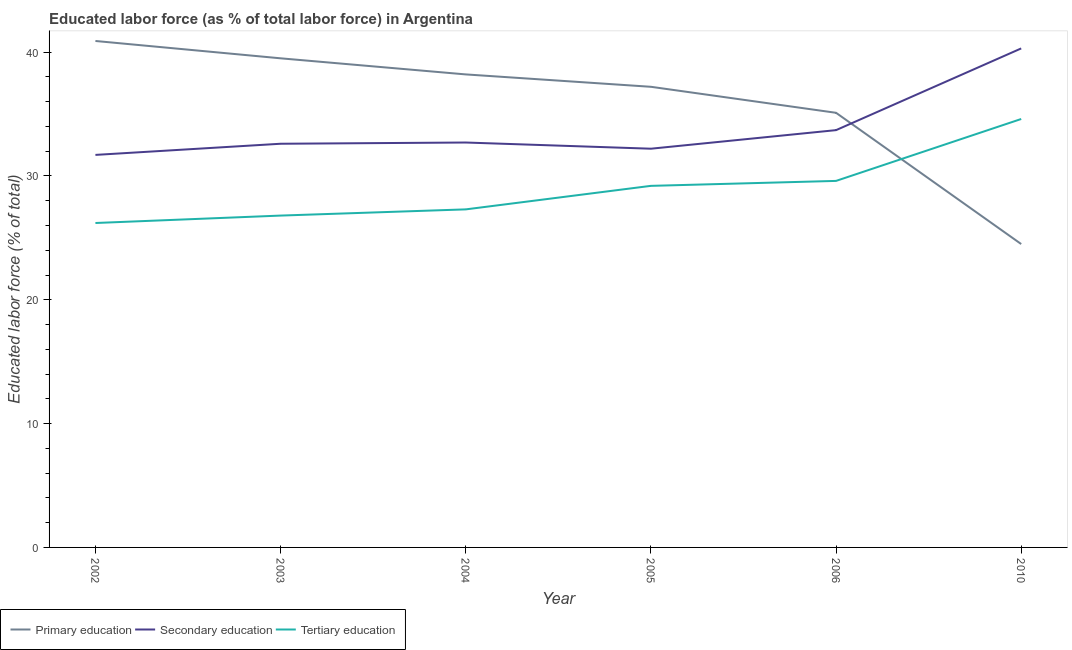Does the line corresponding to percentage of labor force who received secondary education intersect with the line corresponding to percentage of labor force who received tertiary education?
Ensure brevity in your answer.  No. Is the number of lines equal to the number of legend labels?
Offer a terse response. Yes. What is the percentage of labor force who received tertiary education in 2003?
Make the answer very short. 26.8. Across all years, what is the maximum percentage of labor force who received tertiary education?
Your answer should be compact. 34.6. Across all years, what is the minimum percentage of labor force who received tertiary education?
Your answer should be compact. 26.2. In which year was the percentage of labor force who received primary education maximum?
Keep it short and to the point. 2002. In which year was the percentage of labor force who received secondary education minimum?
Your response must be concise. 2002. What is the total percentage of labor force who received secondary education in the graph?
Give a very brief answer. 203.2. What is the difference between the percentage of labor force who received tertiary education in 2005 and that in 2006?
Ensure brevity in your answer.  -0.4. What is the difference between the percentage of labor force who received tertiary education in 2006 and the percentage of labor force who received secondary education in 2005?
Your answer should be compact. -2.6. What is the average percentage of labor force who received tertiary education per year?
Keep it short and to the point. 28.95. In the year 2004, what is the difference between the percentage of labor force who received primary education and percentage of labor force who received tertiary education?
Provide a succinct answer. 10.9. In how many years, is the percentage of labor force who received primary education greater than 10 %?
Offer a terse response. 6. What is the ratio of the percentage of labor force who received secondary education in 2002 to that in 2006?
Offer a very short reply. 0.94. Is the difference between the percentage of labor force who received primary education in 2006 and 2010 greater than the difference between the percentage of labor force who received secondary education in 2006 and 2010?
Give a very brief answer. Yes. What is the difference between the highest and the second highest percentage of labor force who received secondary education?
Your answer should be very brief. 6.6. What is the difference between the highest and the lowest percentage of labor force who received tertiary education?
Make the answer very short. 8.4. In how many years, is the percentage of labor force who received tertiary education greater than the average percentage of labor force who received tertiary education taken over all years?
Offer a terse response. 3. Is the percentage of labor force who received secondary education strictly greater than the percentage of labor force who received tertiary education over the years?
Offer a very short reply. Yes. Is the percentage of labor force who received secondary education strictly less than the percentage of labor force who received primary education over the years?
Your answer should be compact. No. How many years are there in the graph?
Provide a short and direct response. 6. What is the difference between two consecutive major ticks on the Y-axis?
Give a very brief answer. 10. Are the values on the major ticks of Y-axis written in scientific E-notation?
Make the answer very short. No. Does the graph contain any zero values?
Your response must be concise. No. Does the graph contain grids?
Keep it short and to the point. No. How many legend labels are there?
Keep it short and to the point. 3. How are the legend labels stacked?
Keep it short and to the point. Horizontal. What is the title of the graph?
Your response must be concise. Educated labor force (as % of total labor force) in Argentina. Does "Oil sources" appear as one of the legend labels in the graph?
Offer a very short reply. No. What is the label or title of the Y-axis?
Make the answer very short. Educated labor force (% of total). What is the Educated labor force (% of total) of Primary education in 2002?
Keep it short and to the point. 40.9. What is the Educated labor force (% of total) of Secondary education in 2002?
Your answer should be very brief. 31.7. What is the Educated labor force (% of total) of Tertiary education in 2002?
Make the answer very short. 26.2. What is the Educated labor force (% of total) of Primary education in 2003?
Your response must be concise. 39.5. What is the Educated labor force (% of total) in Secondary education in 2003?
Make the answer very short. 32.6. What is the Educated labor force (% of total) in Tertiary education in 2003?
Keep it short and to the point. 26.8. What is the Educated labor force (% of total) in Primary education in 2004?
Provide a succinct answer. 38.2. What is the Educated labor force (% of total) of Secondary education in 2004?
Make the answer very short. 32.7. What is the Educated labor force (% of total) of Tertiary education in 2004?
Offer a very short reply. 27.3. What is the Educated labor force (% of total) of Primary education in 2005?
Make the answer very short. 37.2. What is the Educated labor force (% of total) of Secondary education in 2005?
Make the answer very short. 32.2. What is the Educated labor force (% of total) of Tertiary education in 2005?
Keep it short and to the point. 29.2. What is the Educated labor force (% of total) of Primary education in 2006?
Provide a succinct answer. 35.1. What is the Educated labor force (% of total) in Secondary education in 2006?
Offer a terse response. 33.7. What is the Educated labor force (% of total) of Tertiary education in 2006?
Provide a succinct answer. 29.6. What is the Educated labor force (% of total) of Secondary education in 2010?
Make the answer very short. 40.3. What is the Educated labor force (% of total) of Tertiary education in 2010?
Your answer should be compact. 34.6. Across all years, what is the maximum Educated labor force (% of total) of Primary education?
Your response must be concise. 40.9. Across all years, what is the maximum Educated labor force (% of total) in Secondary education?
Offer a terse response. 40.3. Across all years, what is the maximum Educated labor force (% of total) in Tertiary education?
Keep it short and to the point. 34.6. Across all years, what is the minimum Educated labor force (% of total) of Primary education?
Your answer should be very brief. 24.5. Across all years, what is the minimum Educated labor force (% of total) in Secondary education?
Make the answer very short. 31.7. Across all years, what is the minimum Educated labor force (% of total) of Tertiary education?
Keep it short and to the point. 26.2. What is the total Educated labor force (% of total) of Primary education in the graph?
Your answer should be compact. 215.4. What is the total Educated labor force (% of total) of Secondary education in the graph?
Offer a very short reply. 203.2. What is the total Educated labor force (% of total) of Tertiary education in the graph?
Provide a succinct answer. 173.7. What is the difference between the Educated labor force (% of total) in Primary education in 2002 and that in 2003?
Offer a very short reply. 1.4. What is the difference between the Educated labor force (% of total) in Secondary education in 2002 and that in 2003?
Provide a short and direct response. -0.9. What is the difference between the Educated labor force (% of total) in Tertiary education in 2002 and that in 2003?
Provide a short and direct response. -0.6. What is the difference between the Educated labor force (% of total) in Secondary education in 2002 and that in 2004?
Your answer should be compact. -1. What is the difference between the Educated labor force (% of total) in Tertiary education in 2002 and that in 2004?
Your response must be concise. -1.1. What is the difference between the Educated labor force (% of total) of Primary education in 2002 and that in 2005?
Provide a short and direct response. 3.7. What is the difference between the Educated labor force (% of total) in Secondary education in 2002 and that in 2005?
Your answer should be very brief. -0.5. What is the difference between the Educated labor force (% of total) in Tertiary education in 2002 and that in 2006?
Offer a very short reply. -3.4. What is the difference between the Educated labor force (% of total) in Primary education in 2002 and that in 2010?
Ensure brevity in your answer.  16.4. What is the difference between the Educated labor force (% of total) in Secondary education in 2002 and that in 2010?
Provide a short and direct response. -8.6. What is the difference between the Educated labor force (% of total) in Secondary education in 2003 and that in 2004?
Make the answer very short. -0.1. What is the difference between the Educated labor force (% of total) of Primary education in 2003 and that in 2005?
Ensure brevity in your answer.  2.3. What is the difference between the Educated labor force (% of total) in Secondary education in 2003 and that in 2005?
Provide a short and direct response. 0.4. What is the difference between the Educated labor force (% of total) of Tertiary education in 2003 and that in 2005?
Provide a succinct answer. -2.4. What is the difference between the Educated labor force (% of total) of Primary education in 2003 and that in 2010?
Keep it short and to the point. 15. What is the difference between the Educated labor force (% of total) of Secondary education in 2003 and that in 2010?
Ensure brevity in your answer.  -7.7. What is the difference between the Educated labor force (% of total) in Tertiary education in 2003 and that in 2010?
Your response must be concise. -7.8. What is the difference between the Educated labor force (% of total) of Secondary education in 2004 and that in 2005?
Offer a terse response. 0.5. What is the difference between the Educated labor force (% of total) of Tertiary education in 2004 and that in 2005?
Make the answer very short. -1.9. What is the difference between the Educated labor force (% of total) of Secondary education in 2004 and that in 2006?
Your response must be concise. -1. What is the difference between the Educated labor force (% of total) of Tertiary education in 2004 and that in 2006?
Your response must be concise. -2.3. What is the difference between the Educated labor force (% of total) in Primary education in 2004 and that in 2010?
Keep it short and to the point. 13.7. What is the difference between the Educated labor force (% of total) of Secondary education in 2004 and that in 2010?
Your response must be concise. -7.6. What is the difference between the Educated labor force (% of total) of Secondary education in 2005 and that in 2006?
Keep it short and to the point. -1.5. What is the difference between the Educated labor force (% of total) of Primary education in 2005 and that in 2010?
Make the answer very short. 12.7. What is the difference between the Educated labor force (% of total) of Secondary education in 2005 and that in 2010?
Make the answer very short. -8.1. What is the difference between the Educated labor force (% of total) in Tertiary education in 2006 and that in 2010?
Offer a very short reply. -5. What is the difference between the Educated labor force (% of total) of Secondary education in 2002 and the Educated labor force (% of total) of Tertiary education in 2003?
Provide a short and direct response. 4.9. What is the difference between the Educated labor force (% of total) in Primary education in 2002 and the Educated labor force (% of total) in Secondary education in 2004?
Make the answer very short. 8.2. What is the difference between the Educated labor force (% of total) in Secondary education in 2002 and the Educated labor force (% of total) in Tertiary education in 2004?
Provide a short and direct response. 4.4. What is the difference between the Educated labor force (% of total) of Primary education in 2002 and the Educated labor force (% of total) of Secondary education in 2005?
Offer a very short reply. 8.7. What is the difference between the Educated labor force (% of total) in Secondary education in 2002 and the Educated labor force (% of total) in Tertiary education in 2005?
Your answer should be very brief. 2.5. What is the difference between the Educated labor force (% of total) of Primary education in 2002 and the Educated labor force (% of total) of Secondary education in 2006?
Make the answer very short. 7.2. What is the difference between the Educated labor force (% of total) in Secondary education in 2002 and the Educated labor force (% of total) in Tertiary education in 2006?
Offer a terse response. 2.1. What is the difference between the Educated labor force (% of total) of Primary education in 2002 and the Educated labor force (% of total) of Secondary education in 2010?
Keep it short and to the point. 0.6. What is the difference between the Educated labor force (% of total) in Primary education in 2002 and the Educated labor force (% of total) in Tertiary education in 2010?
Provide a succinct answer. 6.3. What is the difference between the Educated labor force (% of total) in Primary education in 2003 and the Educated labor force (% of total) in Tertiary education in 2004?
Keep it short and to the point. 12.2. What is the difference between the Educated labor force (% of total) of Secondary education in 2003 and the Educated labor force (% of total) of Tertiary education in 2004?
Your response must be concise. 5.3. What is the difference between the Educated labor force (% of total) in Primary education in 2003 and the Educated labor force (% of total) in Tertiary education in 2005?
Your response must be concise. 10.3. What is the difference between the Educated labor force (% of total) of Primary education in 2003 and the Educated labor force (% of total) of Tertiary education in 2006?
Ensure brevity in your answer.  9.9. What is the difference between the Educated labor force (% of total) of Primary education in 2003 and the Educated labor force (% of total) of Secondary education in 2010?
Provide a short and direct response. -0.8. What is the difference between the Educated labor force (% of total) of Secondary education in 2003 and the Educated labor force (% of total) of Tertiary education in 2010?
Keep it short and to the point. -2. What is the difference between the Educated labor force (% of total) of Primary education in 2004 and the Educated labor force (% of total) of Secondary education in 2006?
Keep it short and to the point. 4.5. What is the difference between the Educated labor force (% of total) in Primary education in 2004 and the Educated labor force (% of total) in Tertiary education in 2006?
Provide a succinct answer. 8.6. What is the difference between the Educated labor force (% of total) of Secondary education in 2004 and the Educated labor force (% of total) of Tertiary education in 2006?
Give a very brief answer. 3.1. What is the difference between the Educated labor force (% of total) of Primary education in 2004 and the Educated labor force (% of total) of Secondary education in 2010?
Offer a terse response. -2.1. What is the difference between the Educated labor force (% of total) in Secondary education in 2004 and the Educated labor force (% of total) in Tertiary education in 2010?
Offer a very short reply. -1.9. What is the difference between the Educated labor force (% of total) of Secondary education in 2005 and the Educated labor force (% of total) of Tertiary education in 2006?
Your answer should be very brief. 2.6. What is the difference between the Educated labor force (% of total) in Primary education in 2005 and the Educated labor force (% of total) in Secondary education in 2010?
Your response must be concise. -3.1. What is the difference between the Educated labor force (% of total) in Primary education in 2005 and the Educated labor force (% of total) in Tertiary education in 2010?
Provide a succinct answer. 2.6. What is the difference between the Educated labor force (% of total) in Secondary education in 2005 and the Educated labor force (% of total) in Tertiary education in 2010?
Make the answer very short. -2.4. What is the difference between the Educated labor force (% of total) of Primary education in 2006 and the Educated labor force (% of total) of Secondary education in 2010?
Make the answer very short. -5.2. What is the average Educated labor force (% of total) in Primary education per year?
Provide a short and direct response. 35.9. What is the average Educated labor force (% of total) of Secondary education per year?
Your answer should be compact. 33.87. What is the average Educated labor force (% of total) in Tertiary education per year?
Your answer should be very brief. 28.95. In the year 2002, what is the difference between the Educated labor force (% of total) in Primary education and Educated labor force (% of total) in Tertiary education?
Offer a terse response. 14.7. In the year 2002, what is the difference between the Educated labor force (% of total) in Secondary education and Educated labor force (% of total) in Tertiary education?
Provide a succinct answer. 5.5. In the year 2004, what is the difference between the Educated labor force (% of total) of Primary education and Educated labor force (% of total) of Secondary education?
Keep it short and to the point. 5.5. In the year 2004, what is the difference between the Educated labor force (% of total) of Primary education and Educated labor force (% of total) of Tertiary education?
Offer a very short reply. 10.9. In the year 2006, what is the difference between the Educated labor force (% of total) in Primary education and Educated labor force (% of total) in Secondary education?
Offer a terse response. 1.4. In the year 2010, what is the difference between the Educated labor force (% of total) in Primary education and Educated labor force (% of total) in Secondary education?
Keep it short and to the point. -15.8. In the year 2010, what is the difference between the Educated labor force (% of total) of Primary education and Educated labor force (% of total) of Tertiary education?
Make the answer very short. -10.1. In the year 2010, what is the difference between the Educated labor force (% of total) of Secondary education and Educated labor force (% of total) of Tertiary education?
Offer a terse response. 5.7. What is the ratio of the Educated labor force (% of total) of Primary education in 2002 to that in 2003?
Provide a short and direct response. 1.04. What is the ratio of the Educated labor force (% of total) of Secondary education in 2002 to that in 2003?
Provide a succinct answer. 0.97. What is the ratio of the Educated labor force (% of total) of Tertiary education in 2002 to that in 2003?
Keep it short and to the point. 0.98. What is the ratio of the Educated labor force (% of total) of Primary education in 2002 to that in 2004?
Offer a terse response. 1.07. What is the ratio of the Educated labor force (% of total) of Secondary education in 2002 to that in 2004?
Your answer should be compact. 0.97. What is the ratio of the Educated labor force (% of total) of Tertiary education in 2002 to that in 2004?
Your answer should be compact. 0.96. What is the ratio of the Educated labor force (% of total) of Primary education in 2002 to that in 2005?
Keep it short and to the point. 1.1. What is the ratio of the Educated labor force (% of total) of Secondary education in 2002 to that in 2005?
Offer a terse response. 0.98. What is the ratio of the Educated labor force (% of total) in Tertiary education in 2002 to that in 2005?
Provide a succinct answer. 0.9. What is the ratio of the Educated labor force (% of total) in Primary education in 2002 to that in 2006?
Offer a very short reply. 1.17. What is the ratio of the Educated labor force (% of total) of Secondary education in 2002 to that in 2006?
Provide a short and direct response. 0.94. What is the ratio of the Educated labor force (% of total) in Tertiary education in 2002 to that in 2006?
Provide a short and direct response. 0.89. What is the ratio of the Educated labor force (% of total) of Primary education in 2002 to that in 2010?
Offer a very short reply. 1.67. What is the ratio of the Educated labor force (% of total) of Secondary education in 2002 to that in 2010?
Give a very brief answer. 0.79. What is the ratio of the Educated labor force (% of total) in Tertiary education in 2002 to that in 2010?
Make the answer very short. 0.76. What is the ratio of the Educated labor force (% of total) of Primary education in 2003 to that in 2004?
Give a very brief answer. 1.03. What is the ratio of the Educated labor force (% of total) in Secondary education in 2003 to that in 2004?
Give a very brief answer. 1. What is the ratio of the Educated labor force (% of total) in Tertiary education in 2003 to that in 2004?
Your answer should be very brief. 0.98. What is the ratio of the Educated labor force (% of total) in Primary education in 2003 to that in 2005?
Offer a very short reply. 1.06. What is the ratio of the Educated labor force (% of total) in Secondary education in 2003 to that in 2005?
Provide a succinct answer. 1.01. What is the ratio of the Educated labor force (% of total) of Tertiary education in 2003 to that in 2005?
Provide a short and direct response. 0.92. What is the ratio of the Educated labor force (% of total) of Primary education in 2003 to that in 2006?
Offer a very short reply. 1.13. What is the ratio of the Educated labor force (% of total) in Secondary education in 2003 to that in 2006?
Give a very brief answer. 0.97. What is the ratio of the Educated labor force (% of total) of Tertiary education in 2003 to that in 2006?
Provide a succinct answer. 0.91. What is the ratio of the Educated labor force (% of total) in Primary education in 2003 to that in 2010?
Your answer should be compact. 1.61. What is the ratio of the Educated labor force (% of total) in Secondary education in 2003 to that in 2010?
Make the answer very short. 0.81. What is the ratio of the Educated labor force (% of total) of Tertiary education in 2003 to that in 2010?
Provide a short and direct response. 0.77. What is the ratio of the Educated labor force (% of total) of Primary education in 2004 to that in 2005?
Your answer should be compact. 1.03. What is the ratio of the Educated labor force (% of total) in Secondary education in 2004 to that in 2005?
Make the answer very short. 1.02. What is the ratio of the Educated labor force (% of total) of Tertiary education in 2004 to that in 2005?
Offer a very short reply. 0.93. What is the ratio of the Educated labor force (% of total) in Primary education in 2004 to that in 2006?
Offer a terse response. 1.09. What is the ratio of the Educated labor force (% of total) in Secondary education in 2004 to that in 2006?
Give a very brief answer. 0.97. What is the ratio of the Educated labor force (% of total) of Tertiary education in 2004 to that in 2006?
Your response must be concise. 0.92. What is the ratio of the Educated labor force (% of total) in Primary education in 2004 to that in 2010?
Offer a terse response. 1.56. What is the ratio of the Educated labor force (% of total) of Secondary education in 2004 to that in 2010?
Give a very brief answer. 0.81. What is the ratio of the Educated labor force (% of total) of Tertiary education in 2004 to that in 2010?
Offer a very short reply. 0.79. What is the ratio of the Educated labor force (% of total) in Primary education in 2005 to that in 2006?
Provide a short and direct response. 1.06. What is the ratio of the Educated labor force (% of total) in Secondary education in 2005 to that in 2006?
Your answer should be very brief. 0.96. What is the ratio of the Educated labor force (% of total) in Tertiary education in 2005 to that in 2006?
Make the answer very short. 0.99. What is the ratio of the Educated labor force (% of total) of Primary education in 2005 to that in 2010?
Provide a succinct answer. 1.52. What is the ratio of the Educated labor force (% of total) of Secondary education in 2005 to that in 2010?
Your response must be concise. 0.8. What is the ratio of the Educated labor force (% of total) of Tertiary education in 2005 to that in 2010?
Give a very brief answer. 0.84. What is the ratio of the Educated labor force (% of total) of Primary education in 2006 to that in 2010?
Provide a short and direct response. 1.43. What is the ratio of the Educated labor force (% of total) in Secondary education in 2006 to that in 2010?
Offer a very short reply. 0.84. What is the ratio of the Educated labor force (% of total) of Tertiary education in 2006 to that in 2010?
Keep it short and to the point. 0.86. What is the difference between the highest and the lowest Educated labor force (% of total) in Secondary education?
Keep it short and to the point. 8.6. 